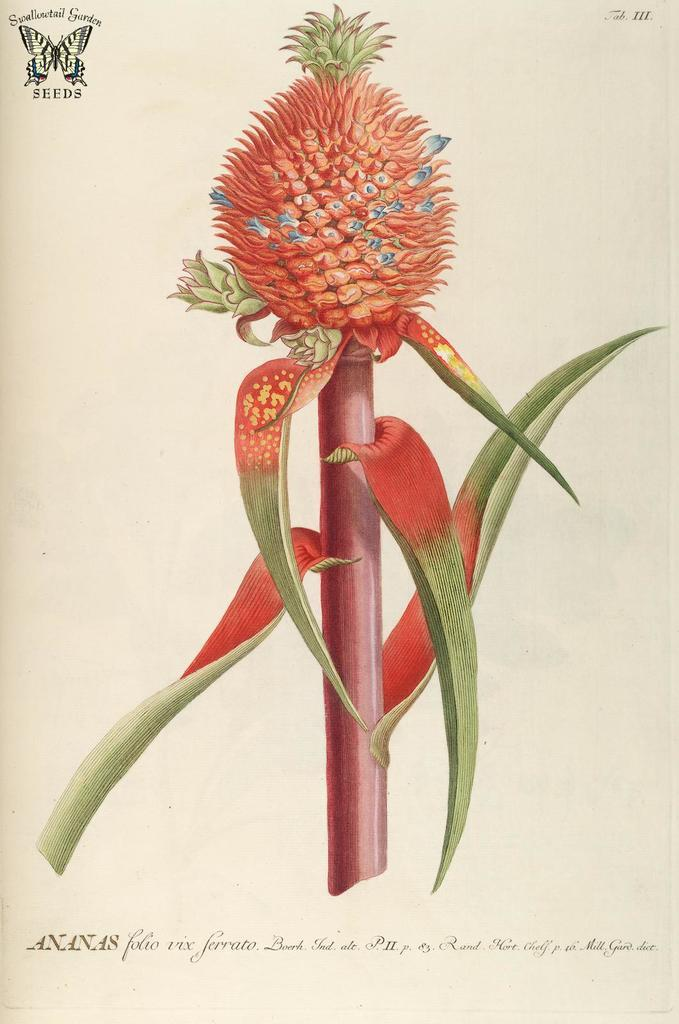What type of plant is present in the image? The image contains a pineapple plant with leaves. What can be seen in the background of the image? There is a logo and some text visible in the background of the image. How many people are in the crowd surrounding the pineapple plant in the image? There is no crowd present in the image; it only features a pineapple plant and background elements. 